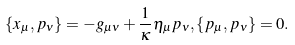<formula> <loc_0><loc_0><loc_500><loc_500>\{ x _ { \mu } , p _ { \nu } \} = - g _ { \mu \nu } + \frac { 1 } { \kappa } \eta _ { \mu } p _ { \nu } , \{ p _ { \mu } , p _ { \nu } \} = 0 .</formula> 